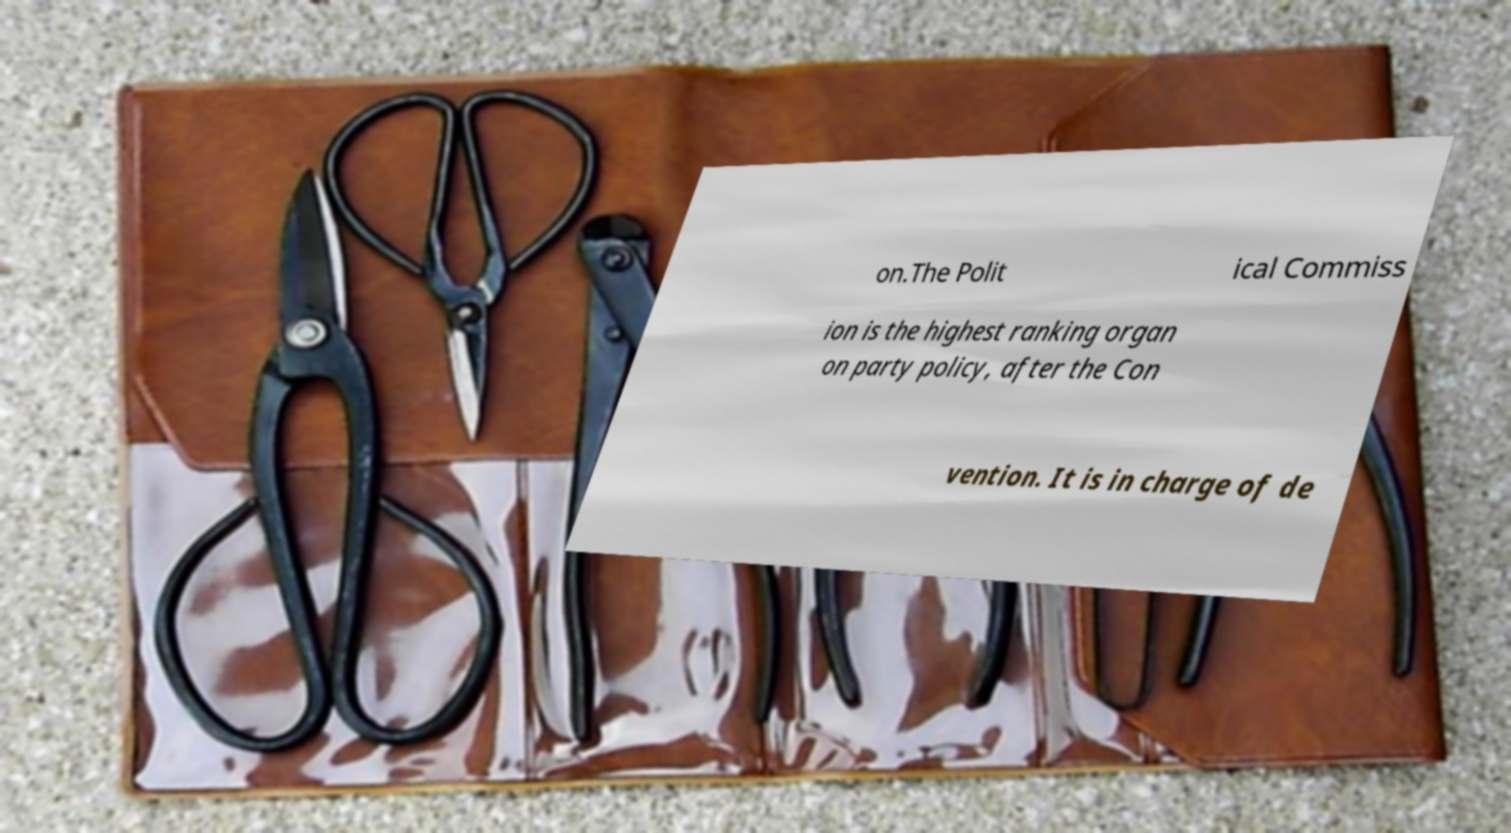What messages or text are displayed in this image? I need them in a readable, typed format. on.The Polit ical Commiss ion is the highest ranking organ on party policy, after the Con vention. It is in charge of de 